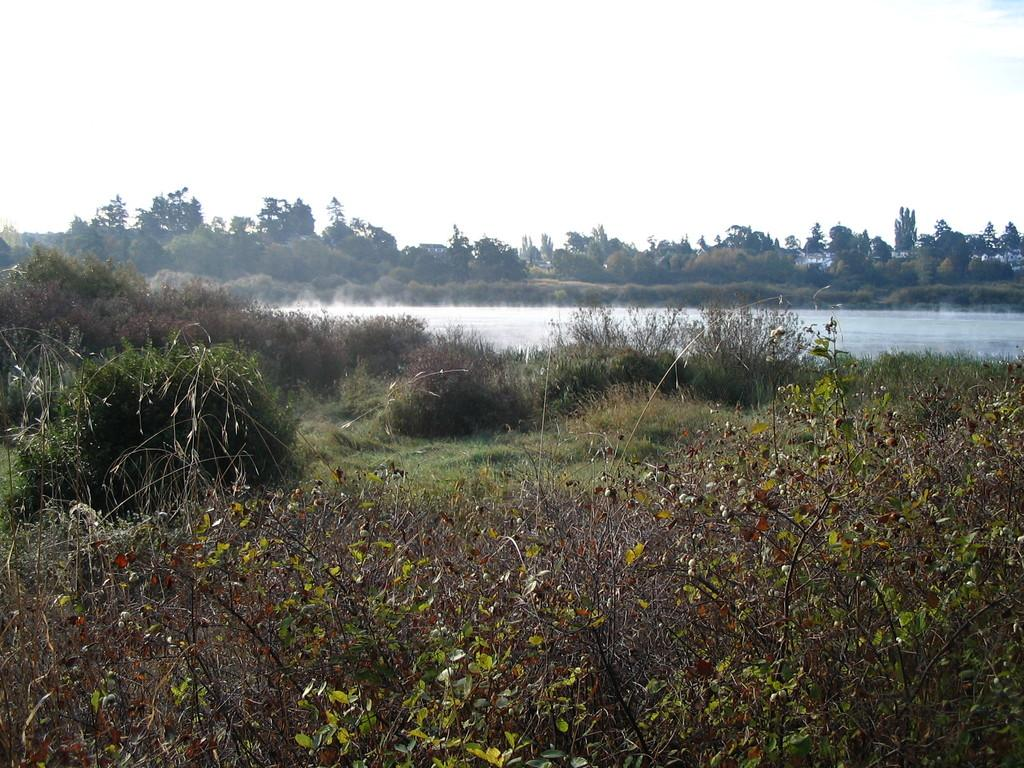What type of vegetation can be seen in the image? There are plants, trees, and grass visible in the image. What natural element is present in the image? Water is visible in the image. What can be seen in the background of the image? The sky is visible in the background of the image. What shape is the cracker in the image? There is no cracker present in the image. How many birds can be seen flying in the image? There are no birds visible in the image. 